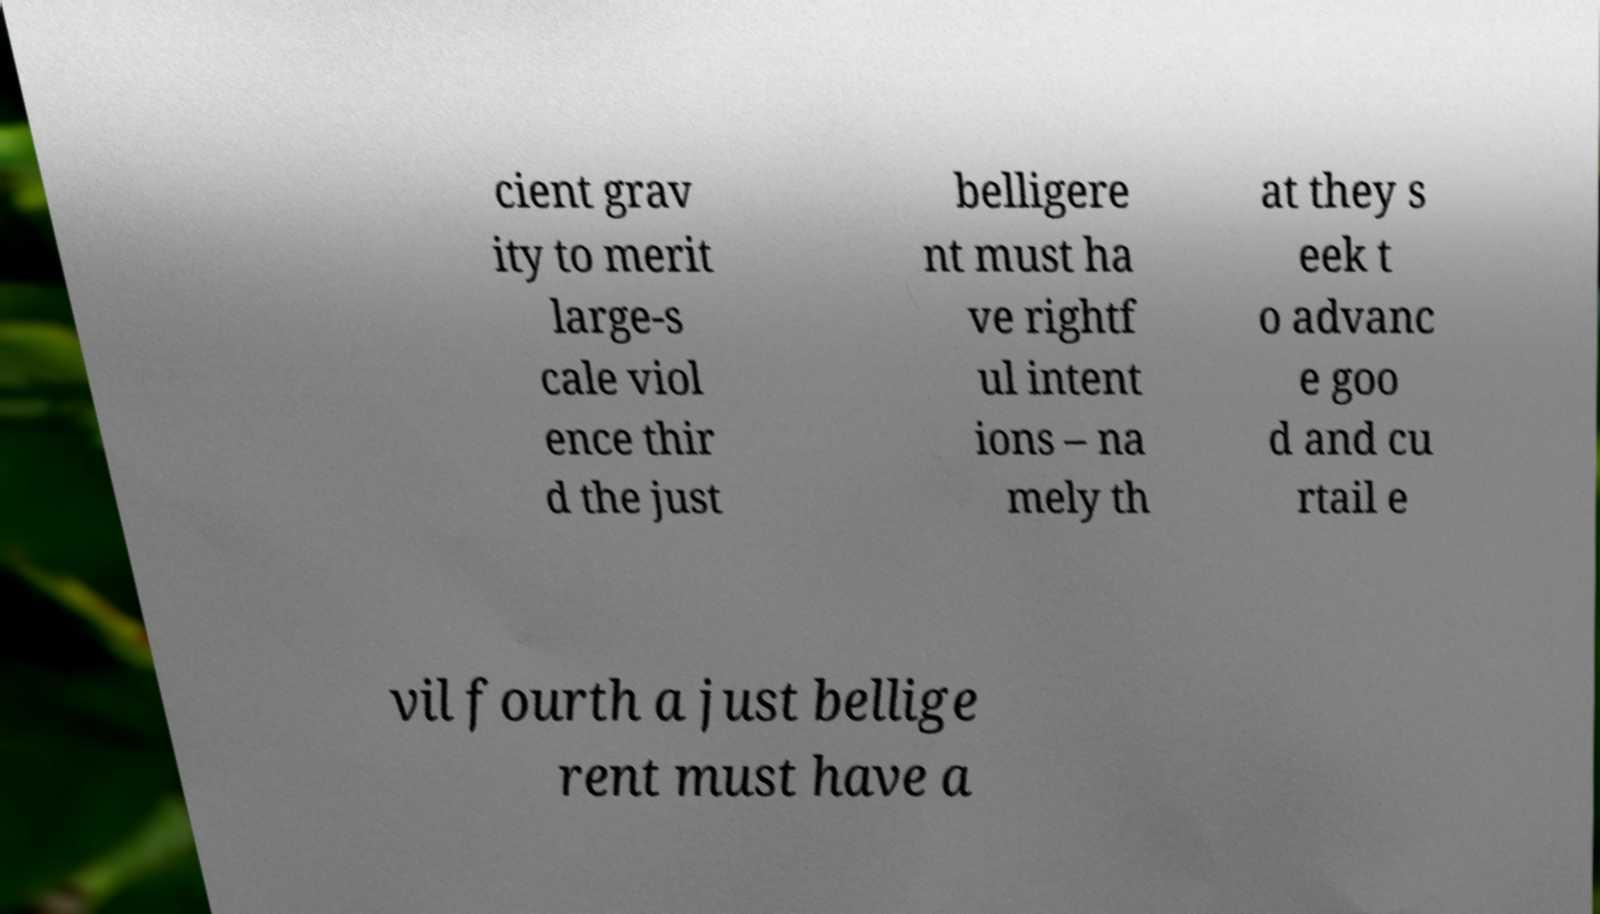Can you accurately transcribe the text from the provided image for me? cient grav ity to merit large-s cale viol ence thir d the just belligere nt must ha ve rightf ul intent ions – na mely th at they s eek t o advanc e goo d and cu rtail e vil fourth a just bellige rent must have a 